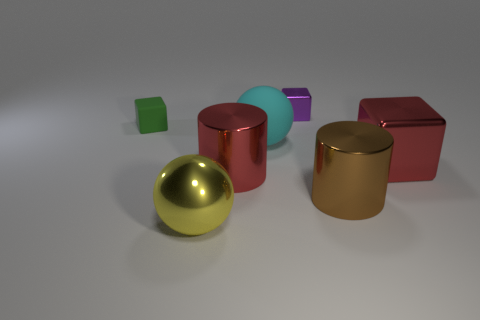There is a small purple object; what shape is it?
Offer a very short reply. Cube. Are there any other things that have the same size as the rubber cube?
Make the answer very short. Yes. Are there more big rubber balls that are left of the big red cylinder than large red balls?
Your response must be concise. No. What shape is the big metallic thing that is to the left of the big red metallic thing that is to the left of the large red metallic block right of the large rubber sphere?
Give a very brief answer. Sphere. Is the size of the cylinder in front of the red cylinder the same as the tiny purple thing?
Make the answer very short. No. What is the shape of the big metal object that is both behind the big yellow metallic ball and on the left side of the tiny purple block?
Offer a terse response. Cylinder. There is a large metal cube; is it the same color as the metal object behind the green matte thing?
Provide a short and direct response. No. What color is the metal thing that is to the left of the large red object that is on the left side of the matte thing that is on the right side of the matte block?
Offer a terse response. Yellow. There is another large object that is the same shape as the big yellow shiny object; what color is it?
Ensure brevity in your answer.  Cyan. Is the number of brown metal cylinders that are in front of the big brown cylinder the same as the number of big brown objects?
Make the answer very short. No. 